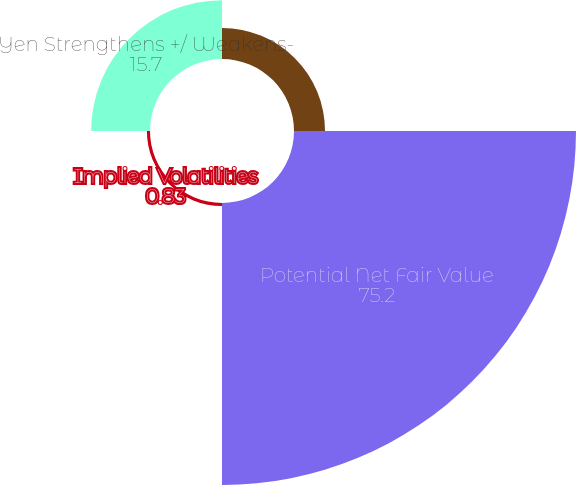Convert chart. <chart><loc_0><loc_0><loc_500><loc_500><pie_chart><fcel>Equity Market Return<fcel>Potential Net Fair Value<fcel>Implied Volatilities<fcel>Yen Strengthens +/ Weakens-<nl><fcel>8.27%<fcel>75.2%<fcel>0.83%<fcel>15.7%<nl></chart> 